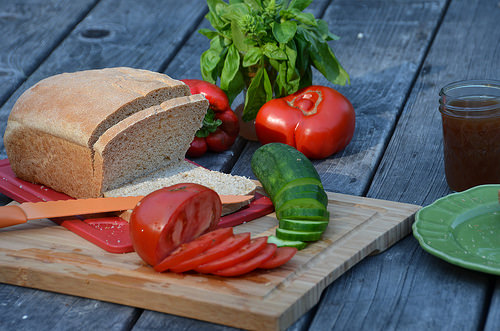<image>
Is there a bread on the table? Yes. Looking at the image, I can see the bread is positioned on top of the table, with the table providing support. 